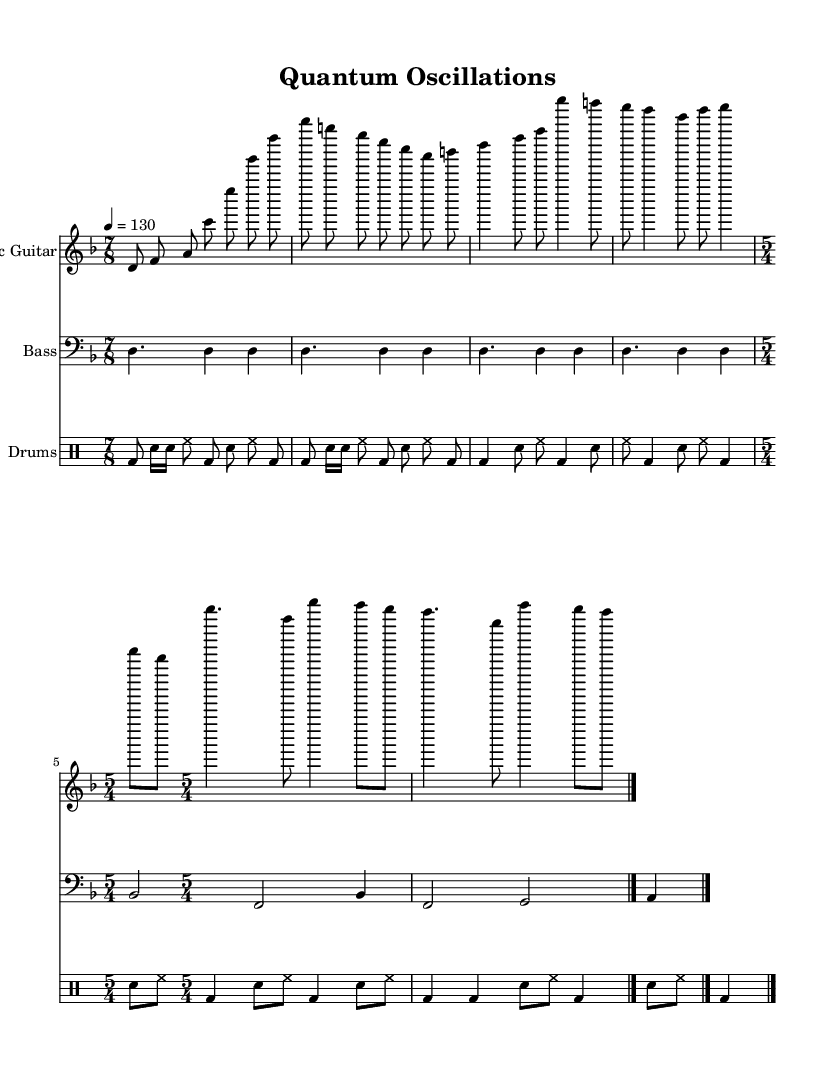What is the key signature of this music? The key signature is indicated by the sharp or flat symbols, but here there are none present, showing that the music is in D minor with one flat marking that is understood implicitly through its association.
Answer: D minor What is the tempo marking of the piece? The tempo marking is indicated near the start of the score, showing the beats per minute, which is specified numerically. Here it states the tempo is 130 beats per minute as 4 equals 130.
Answer: 130 What are the time signatures used in the sections of this piece? The piece begins with a time signature of 7/8, indicated at the start of the electric guitar and bass guitar parts. It later shifts to a 5/4 time signature in both the electric guitar and bass guitar parts as indicated when the time signature changes.
Answer: 7/8 and 5/4 How many measures are there in the 7/8 section for electric guitar? To find the number of measures, we can count the beats grouped by the time signature of 7/8 in the electric guitar part; there are 4 measures in total, each containing 7 eighth notes.
Answer: 4 What rhythmic complexity is present in the drums section? The drums section displays rhythmic complexity through the use of syncopated patterns across various subdivisions such as eighth notes and sixteenth notes within the 7/8 time signature, contributing to a feeling of unevenness characteristic of progressive rock.
Answer: Syncopation What overarching theme is suggested by the title and the scientific elements of the music? The title "Quantum Oscillations" implies a connection to quantum physics, suggesting that the music's structure may reflect principles or concepts such as uncertainty or wave functions, fitting seamlessly within the scientific narrative common in progressive rock.
Answer: Scientific themes 